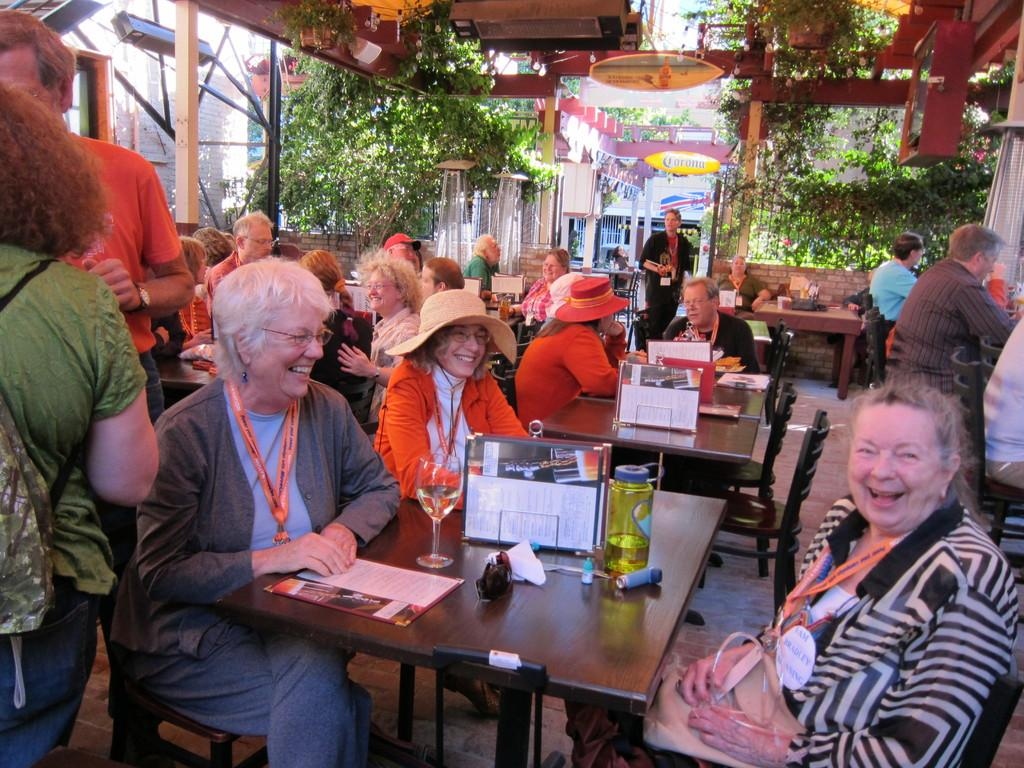What is happening with the group of people in the image? There is a group of people sitting in the image. Can you describe the interaction between the woman and the person she is looking at? The woman is staring at a person and laughing. What can be seen in the background of the image? There are plants in the background of the image. What type of silk is being used to make the box in the image? There is no box or silk present in the image. How many mice can be seen running around in the image? There are no mice present in the image. 